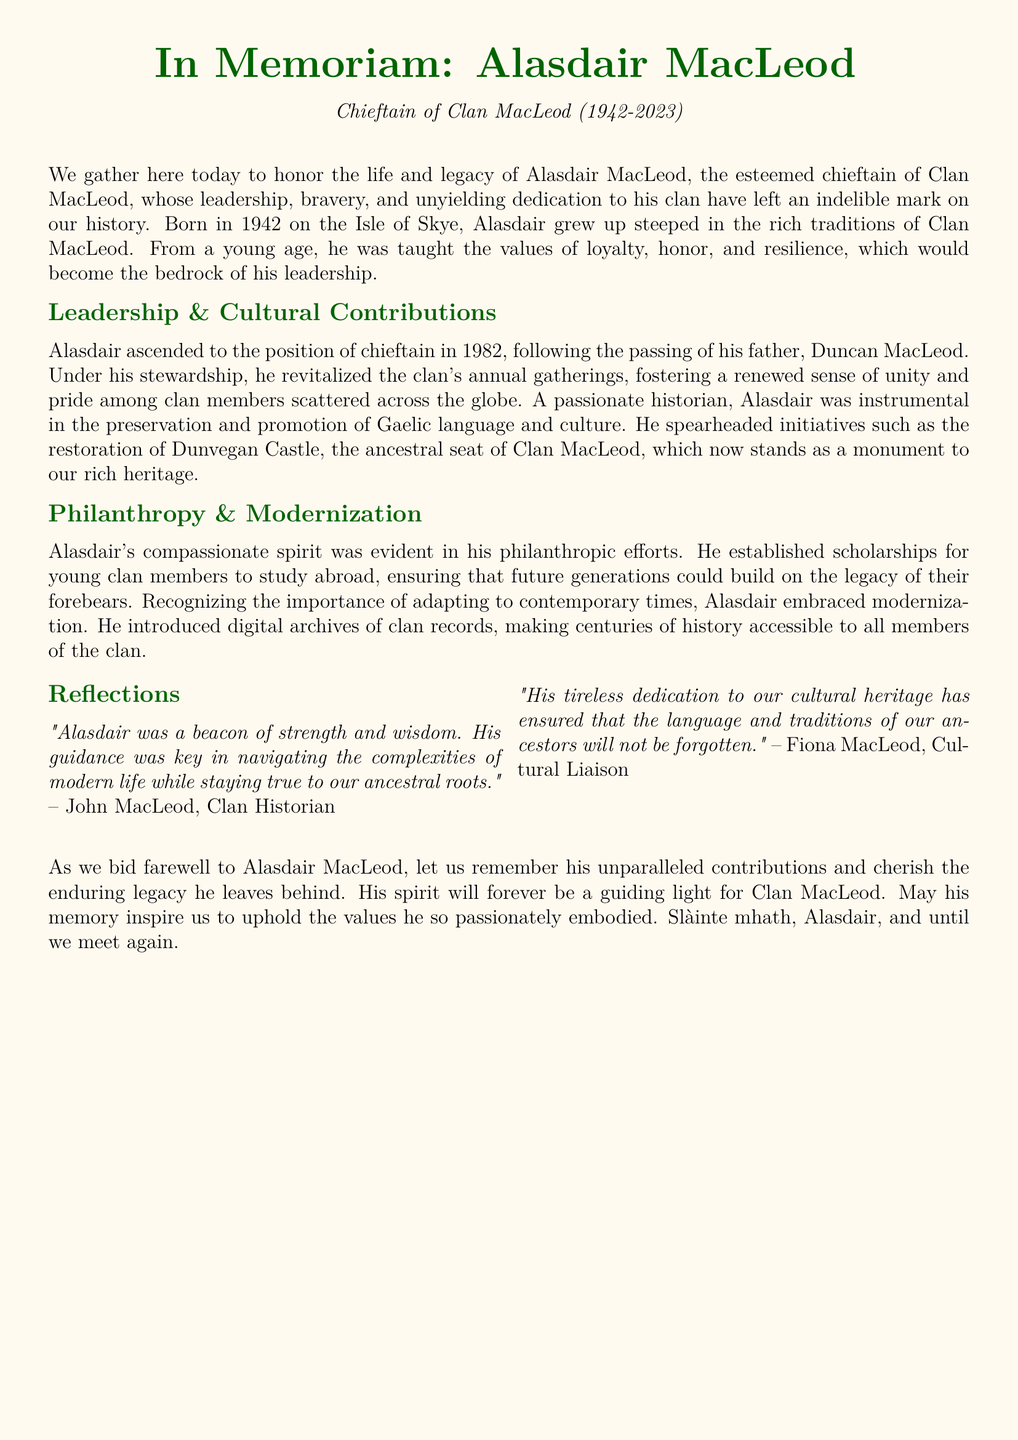What is the name of the chieftain? The document states the name of the chieftain as Alasdair MacLeod.
Answer: Alasdair MacLeod In what year was Alasdair MacLeod born? The document indicates that Alasdair was born in the year 1942.
Answer: 1942 What was the role of Duncan MacLeod? Alasdair ascended to the position of chieftain following the passing of his father, Duncan MacLeod, indicating Duncan's role as a former chieftain.
Answer: Chieftain What major initiative did Alasdair MacLeod champion for Clan MacLeod? The document mentions that Alasdair revitalized the clan's annual gatherings as a major initiative.
Answer: Annual gatherings What cultural aspect did Alasdair MacLeod promote? The document notes his efforts in the preservation and promotion of the Gaelic language and culture.
Answer: Gaelic language What was one of Alasdair's philanthropic efforts? The document states that Alasdair established scholarships for young clan members to study abroad as a philanthropic effort.
Answer: Scholarships What did Alasdair MacLeod introduce for clan records? The document indicates that he introduced digital archives for clan records.
Answer: Digital archives According to the clan historian, what qualities did Alasdair exhibit? The clan historian reflects that Alasdair was a beacon of strength and wisdom, indicating his qualities.
Answer: Strength and wisdom What is a lasting impact of Alasdair MacLeod's legacy? The document suggests that his dedication to cultural heritage ensures the language and traditions of ancestors will not be forgotten.
Answer: Cultural heritage 